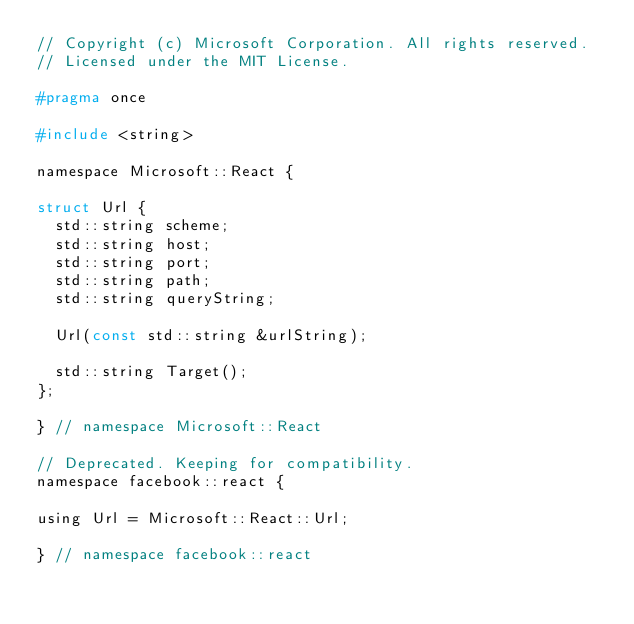Convert code to text. <code><loc_0><loc_0><loc_500><loc_500><_C_>// Copyright (c) Microsoft Corporation. All rights reserved.
// Licensed under the MIT License.

#pragma once

#include <string>

namespace Microsoft::React {

struct Url {
  std::string scheme;
  std::string host;
  std::string port;
  std::string path;
  std::string queryString;

  Url(const std::string &urlString);

  std::string Target();
};

} // namespace Microsoft::React

// Deprecated. Keeping for compatibility.
namespace facebook::react {

using Url = Microsoft::React::Url;

} // namespace facebook::react
</code> 